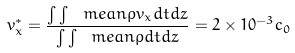Convert formula to latex. <formula><loc_0><loc_0><loc_500><loc_500>v _ { x } ^ { * } = \frac { \int \int \ m e a n { \rho v _ { x } } d t d z } { \int \int \ m e a n { \rho } d t d z } = 2 \times 1 0 ^ { - 3 } c _ { 0 }</formula> 